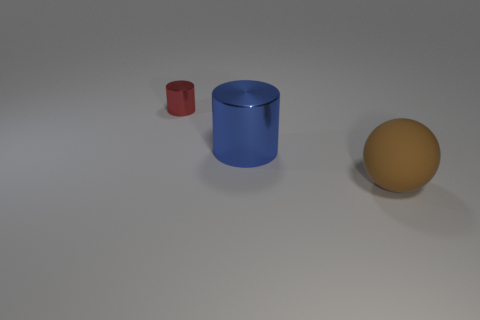Are there an equal number of big blue metal things left of the big blue shiny cylinder and big brown rubber objects on the left side of the red object?
Your answer should be compact. Yes. The blue cylinder that is made of the same material as the small red cylinder is what size?
Your answer should be compact. Large. The large sphere is what color?
Offer a terse response. Brown. There is another thing that is the same size as the brown object; what is it made of?
Give a very brief answer. Metal. There is a metal cylinder to the right of the tiny metallic object; is there a metallic object behind it?
Provide a short and direct response. Yes. How big is the blue metallic cylinder?
Your answer should be very brief. Large. Is there a large brown matte thing?
Give a very brief answer. Yes. Is the number of big blue cylinders on the left side of the large brown rubber thing greater than the number of tiny metal objects that are on the right side of the blue metal cylinder?
Your response must be concise. Yes. What material is the object that is in front of the tiny red cylinder and behind the brown matte thing?
Your response must be concise. Metal. Is the shape of the small red thing the same as the blue shiny object?
Offer a very short reply. Yes. 